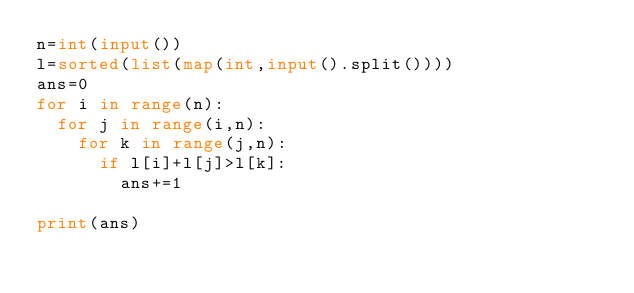<code> <loc_0><loc_0><loc_500><loc_500><_Python_>n=int(input())
l=sorted(list(map(int,input().split())))
ans=0
for i in range(n):
  for j in range(i,n):
    for k in range(j,n):
      if l[i]+l[j]>l[k]:
        ans+=1

print(ans)</code> 